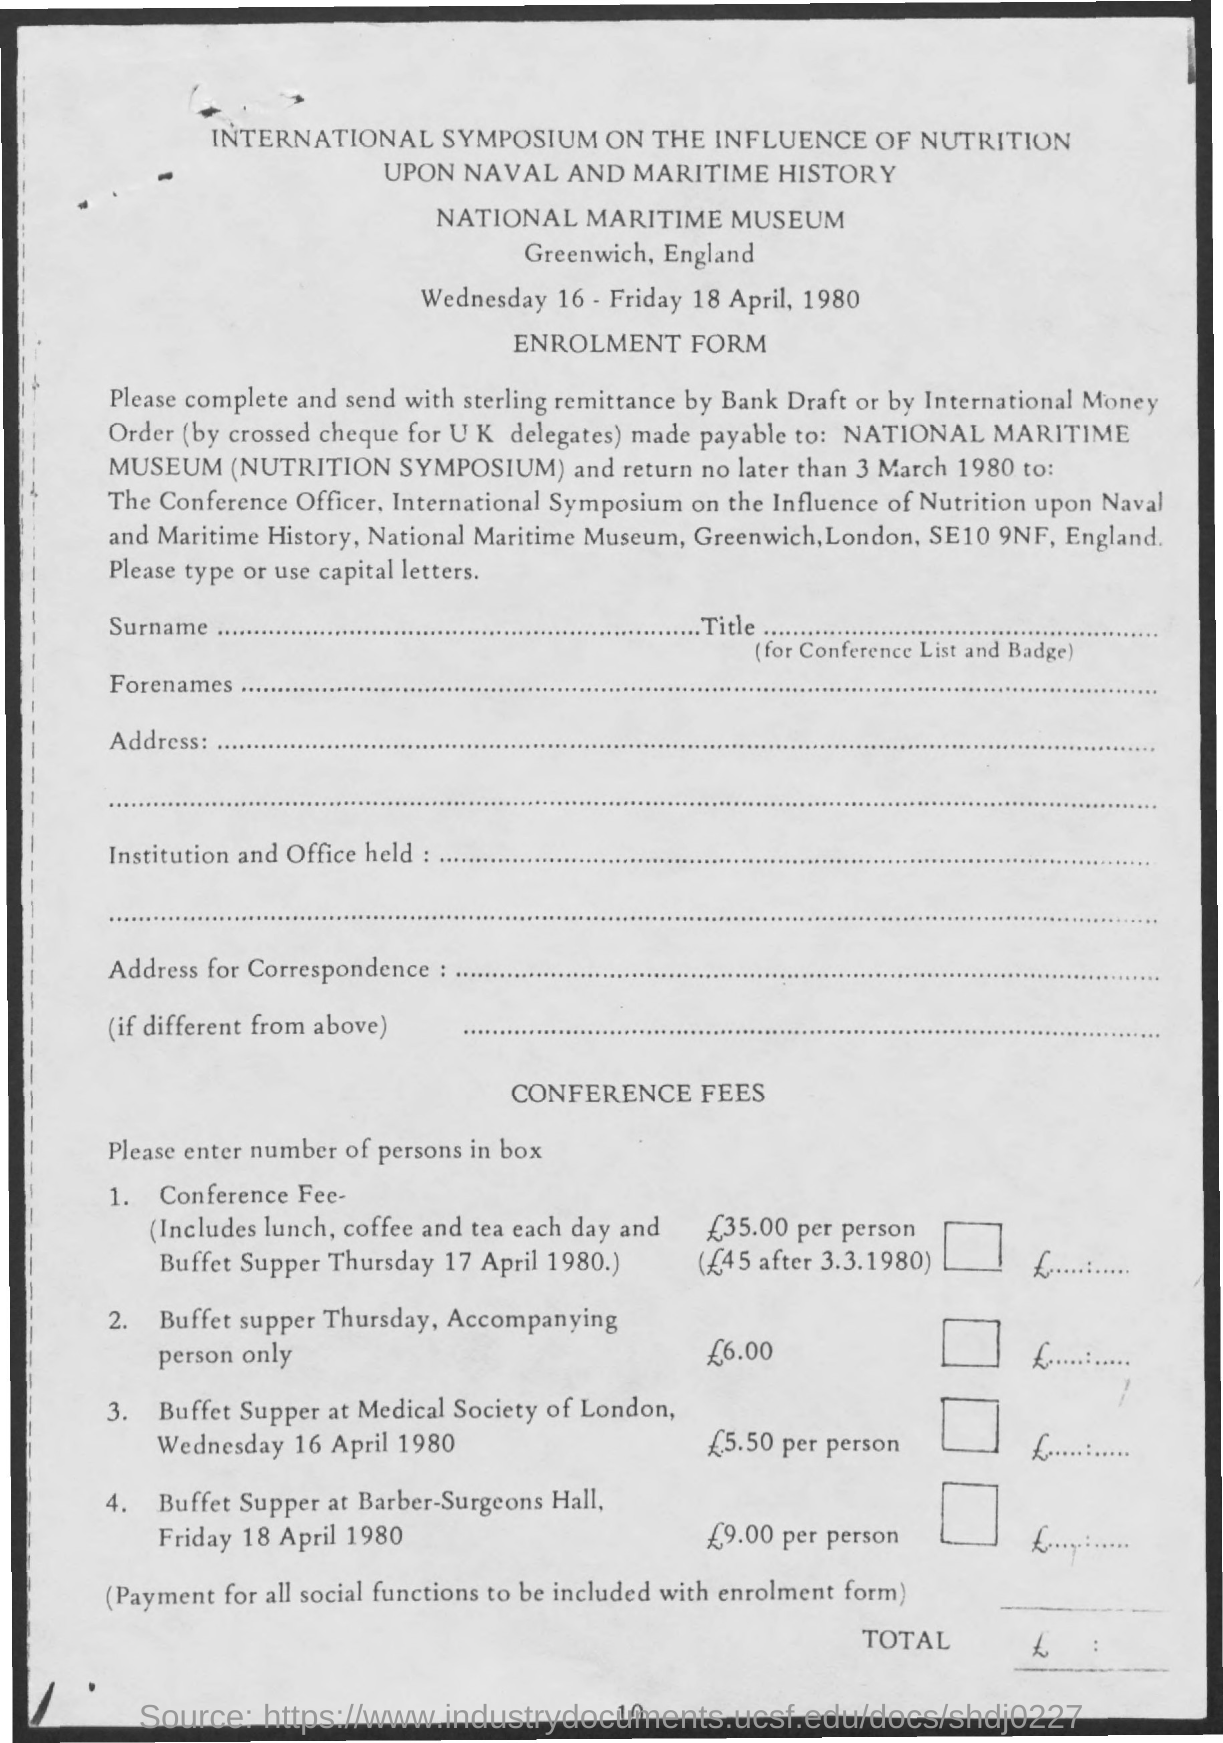Highlight a few significant elements in this photo. The document is titled 'International Symposium on the Influence of Nutrition on the Health of the US Population,' which was held in 1968. The National Maritime Museum is the name of the museum. The page number is 10," the speaker declared. The Enrolment Form is the name of the form. 